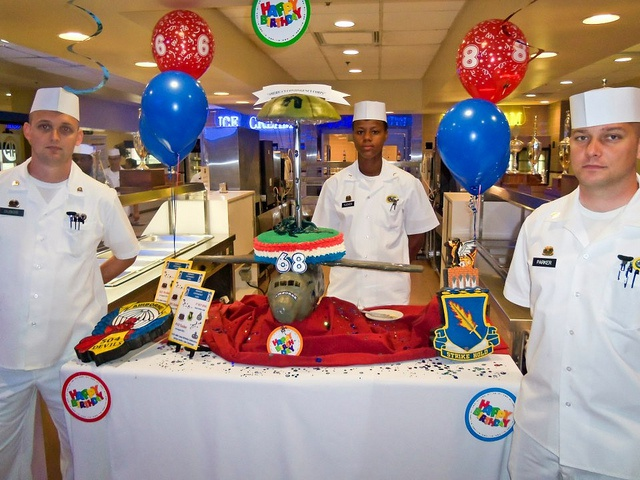Describe the objects in this image and their specific colors. I can see dining table in olive, darkgray, lightgray, and brown tones, people in olive, lightgray, and darkgray tones, people in olive, lightgray, darkgray, and brown tones, people in olive, lightgray, darkgray, and maroon tones, and cake in olive, gray, and black tones in this image. 